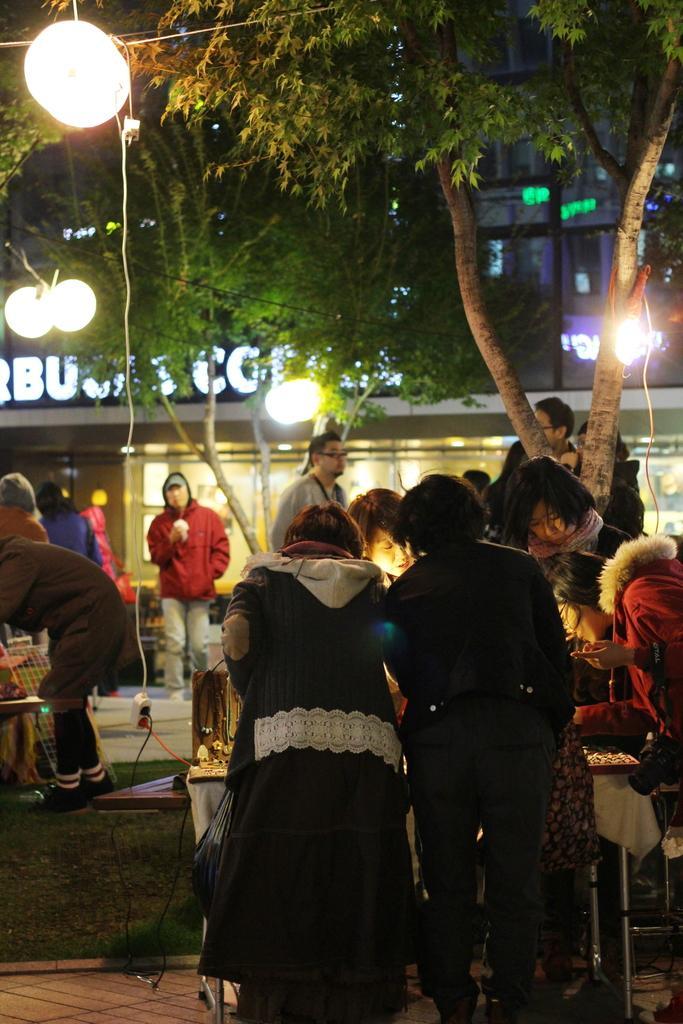Please provide a concise description of this image. On the right side, there are persons in different color dresses, standing in front of a table on which there are some objects. In the background, there are other persons, there's grass on the ground and there is a building which is having a hoarding. 